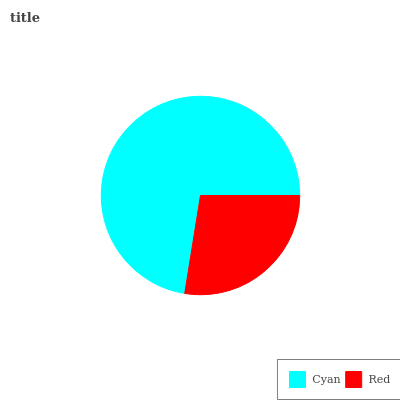Is Red the minimum?
Answer yes or no. Yes. Is Cyan the maximum?
Answer yes or no. Yes. Is Red the maximum?
Answer yes or no. No. Is Cyan greater than Red?
Answer yes or no. Yes. Is Red less than Cyan?
Answer yes or no. Yes. Is Red greater than Cyan?
Answer yes or no. No. Is Cyan less than Red?
Answer yes or no. No. Is Cyan the high median?
Answer yes or no. Yes. Is Red the low median?
Answer yes or no. Yes. Is Red the high median?
Answer yes or no. No. Is Cyan the low median?
Answer yes or no. No. 